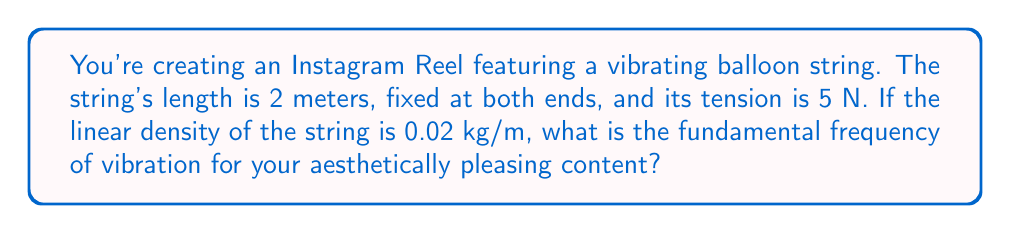Could you help me with this problem? Let's approach this step-by-step using the wave equation:

1) The wave equation for a vibrating string is:

   $$\frac{\partial^2 y}{\partial t^2} = v^2 \frac{\partial^2 y}{\partial x^2}$$

   where $v$ is the wave speed.

2) The wave speed $v$ is given by:

   $$v = \sqrt{\frac{T}{\mu}}$$

   where $T$ is the tension and $\mu$ is the linear density.

3) Given:
   - Tension $T = 5$ N
   - Linear density $\mu = 0.02$ kg/m

4) Calculate the wave speed:

   $$v = \sqrt{\frac{5}{0.02}} = \sqrt{250} = 15.81$ m/s$

5) The fundamental frequency $f$ for a string fixed at both ends is given by:

   $$f = \frac{v}{2L}$$

   where $L$ is the length of the string.

6) Given:
   - Length $L = 2$ m

7) Calculate the fundamental frequency:

   $$f = \frac{15.81}{2(2)} = \frac{15.81}{4} = 3.95$ Hz$

Therefore, the fundamental frequency of the vibrating balloon string is approximately 3.95 Hz.
Answer: 3.95 Hz 